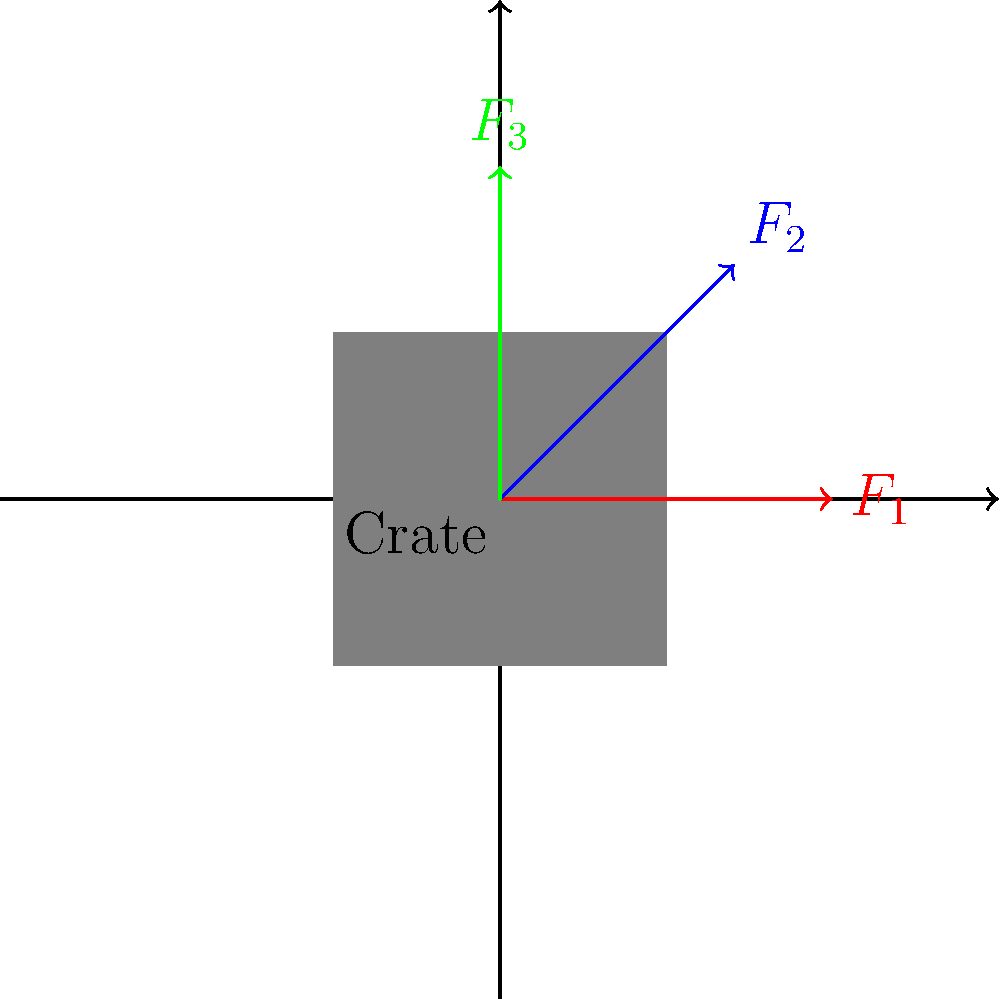In a VR game, you're testing the physics of pushing a virtual crate. The diagram shows three force vectors ($F_1$, $F_2$, and $F_3$) applied to the crate. If the magnitude of $F_1$ is 100 N and all vectors have the same length, calculate the magnitude of the vertical component of $F_2$. How might this affect the player's perception of effort when pushing the crate in different directions? To solve this problem, let's follow these steps:

1) First, we need to understand the directions of the forces:
   $F_1$ is horizontal (0°)
   $F_2$ is at a 45° angle
   $F_3$ is vertical (90°)

2) Since all vectors have the same length and $F_1$ is 100 N, we know that $F_2$ and $F_3$ also have a magnitude of 100 N.

3) To find the vertical component of $F_2$, we need to use trigonometry:
   Vertical component = $F_2 \times \sin(45°)$

4) $\sin(45°) = \frac{\sqrt{2}}{2} \approx 0.707$

5) Therefore, the vertical component of $F_2$ is:
   $100 \text{ N} \times 0.707 = 70.7 \text{ N}$

6) Regarding the player's perception:
   - Pushing horizontally ($F_1$) might feel easier as it's a natural motion.
   - Pushing at an angle ($F_2$) could feel more challenging due to the combined horizontal and vertical components.
   - Pushing straight up ($F_3$) might feel the most difficult due to working directly against gravity.

7) This variation in perceived effort could enhance the realism of the VR experience, making different pushing directions feel appropriately challenging.
Answer: 70.7 N; Players may perceive varying levels of effort based on pushing direction. 